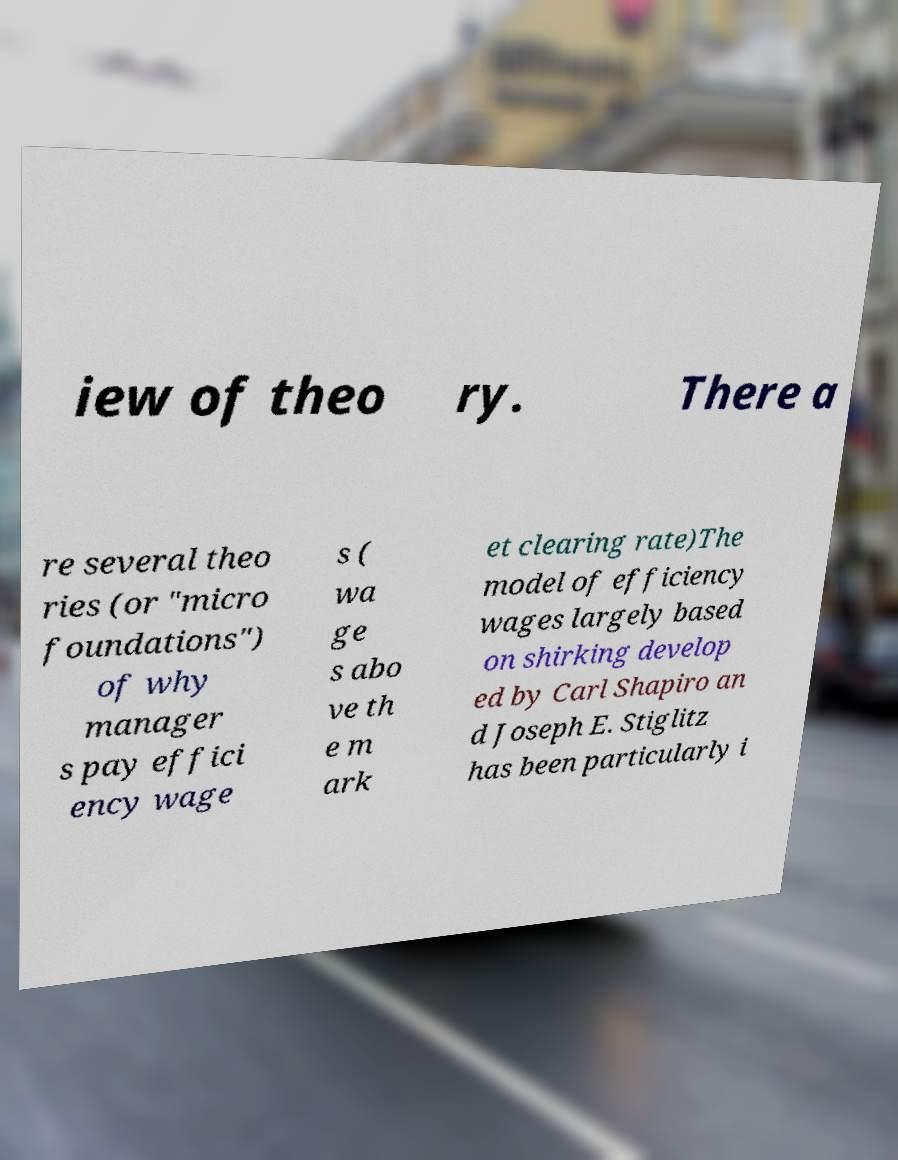Can you accurately transcribe the text from the provided image for me? iew of theo ry. There a re several theo ries (or "micro foundations") of why manager s pay effici ency wage s ( wa ge s abo ve th e m ark et clearing rate)The model of efficiency wages largely based on shirking develop ed by Carl Shapiro an d Joseph E. Stiglitz has been particularly i 